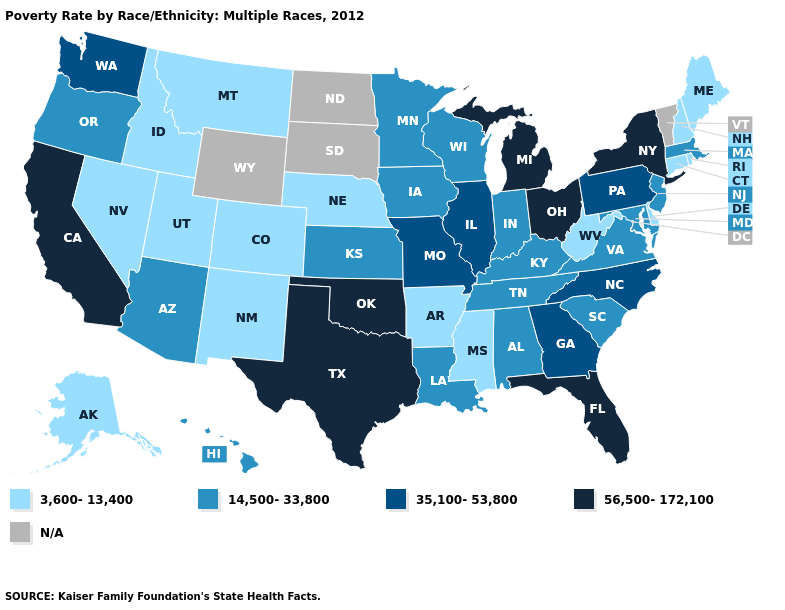Name the states that have a value in the range 3,600-13,400?
Answer briefly. Alaska, Arkansas, Colorado, Connecticut, Delaware, Idaho, Maine, Mississippi, Montana, Nebraska, Nevada, New Hampshire, New Mexico, Rhode Island, Utah, West Virginia. Name the states that have a value in the range 56,500-172,100?
Keep it brief. California, Florida, Michigan, New York, Ohio, Oklahoma, Texas. Is the legend a continuous bar?
Keep it brief. No. Among the states that border Missouri , does Iowa have the highest value?
Give a very brief answer. No. What is the highest value in the USA?
Keep it brief. 56,500-172,100. Name the states that have a value in the range 14,500-33,800?
Answer briefly. Alabama, Arizona, Hawaii, Indiana, Iowa, Kansas, Kentucky, Louisiana, Maryland, Massachusetts, Minnesota, New Jersey, Oregon, South Carolina, Tennessee, Virginia, Wisconsin. What is the lowest value in the MidWest?
Answer briefly. 3,600-13,400. Which states hav the highest value in the South?
Keep it brief. Florida, Oklahoma, Texas. Among the states that border Pennsylvania , which have the lowest value?
Concise answer only. Delaware, West Virginia. What is the value of Tennessee?
Write a very short answer. 14,500-33,800. What is the value of West Virginia?
Give a very brief answer. 3,600-13,400. Among the states that border Arkansas , which have the highest value?
Answer briefly. Oklahoma, Texas. What is the value of New York?
Answer briefly. 56,500-172,100. Does Arizona have the lowest value in the USA?
Write a very short answer. No. Among the states that border Pennsylvania , which have the lowest value?
Short answer required. Delaware, West Virginia. 